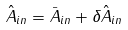<formula> <loc_0><loc_0><loc_500><loc_500>\hat { A } _ { i n } = \bar { A } _ { i n } + \delta \hat { A } _ { i n }</formula> 